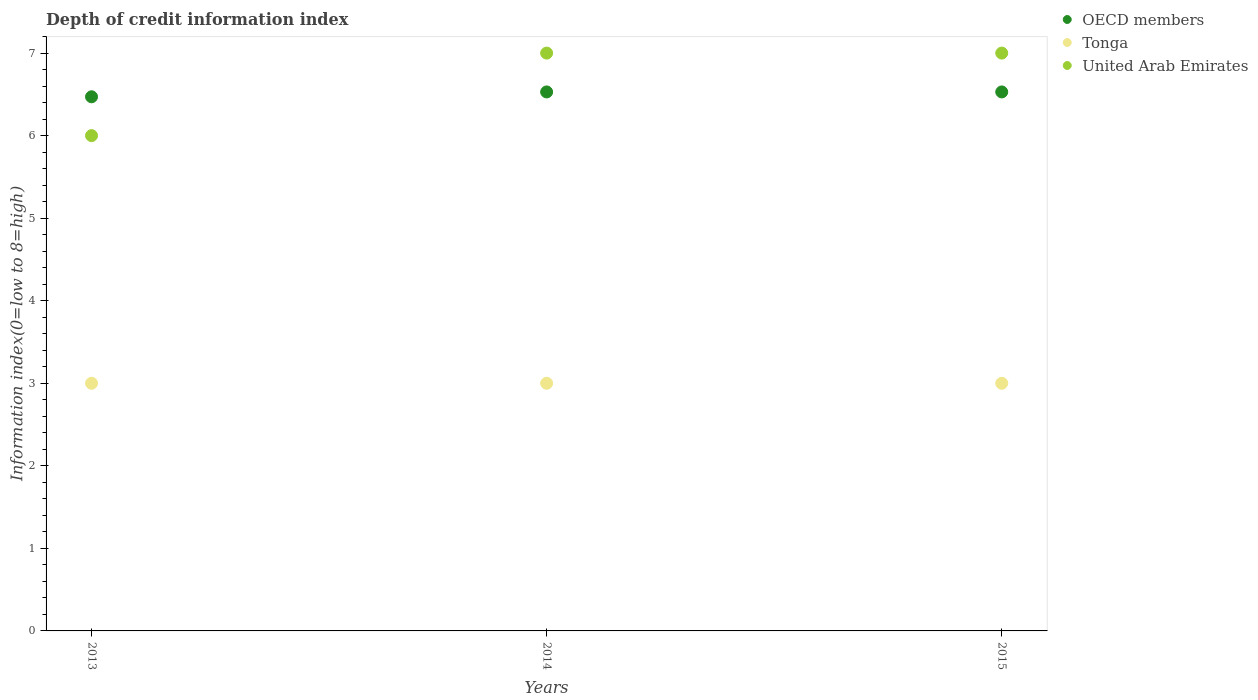How many different coloured dotlines are there?
Ensure brevity in your answer.  3. What is the information index in OECD members in 2014?
Give a very brief answer. 6.53. Across all years, what is the maximum information index in Tonga?
Your answer should be very brief. 3. In which year was the information index in United Arab Emirates maximum?
Keep it short and to the point. 2014. In which year was the information index in Tonga minimum?
Your answer should be compact. 2013. What is the total information index in United Arab Emirates in the graph?
Offer a very short reply. 20. What is the difference between the information index in OECD members in 2013 and that in 2014?
Your answer should be compact. -0.06. What is the difference between the information index in United Arab Emirates in 2015 and the information index in OECD members in 2013?
Keep it short and to the point. 0.53. What is the average information index in OECD members per year?
Give a very brief answer. 6.51. In the year 2014, what is the difference between the information index in OECD members and information index in Tonga?
Provide a short and direct response. 3.53. Is the information index in Tonga in 2013 less than that in 2014?
Provide a short and direct response. No. Is the difference between the information index in OECD members in 2014 and 2015 greater than the difference between the information index in Tonga in 2014 and 2015?
Your answer should be very brief. No. What is the difference between the highest and the second highest information index in Tonga?
Provide a short and direct response. 0. What is the difference between the highest and the lowest information index in United Arab Emirates?
Provide a short and direct response. 1. Is it the case that in every year, the sum of the information index in Tonga and information index in OECD members  is greater than the information index in United Arab Emirates?
Make the answer very short. Yes. Does the information index in OECD members monotonically increase over the years?
Keep it short and to the point. No. Is the information index in OECD members strictly greater than the information index in United Arab Emirates over the years?
Your response must be concise. No. How many dotlines are there?
Provide a succinct answer. 3. How many years are there in the graph?
Keep it short and to the point. 3. What is the difference between two consecutive major ticks on the Y-axis?
Make the answer very short. 1. Are the values on the major ticks of Y-axis written in scientific E-notation?
Offer a very short reply. No. Does the graph contain any zero values?
Provide a short and direct response. No. How many legend labels are there?
Give a very brief answer. 3. What is the title of the graph?
Your response must be concise. Depth of credit information index. What is the label or title of the Y-axis?
Keep it short and to the point. Information index(0=low to 8=high). What is the Information index(0=low to 8=high) of OECD members in 2013?
Ensure brevity in your answer.  6.47. What is the Information index(0=low to 8=high) of United Arab Emirates in 2013?
Offer a terse response. 6. What is the Information index(0=low to 8=high) in OECD members in 2014?
Keep it short and to the point. 6.53. What is the Information index(0=low to 8=high) in OECD members in 2015?
Offer a very short reply. 6.53. What is the Information index(0=low to 8=high) of Tonga in 2015?
Make the answer very short. 3. Across all years, what is the maximum Information index(0=low to 8=high) of OECD members?
Make the answer very short. 6.53. Across all years, what is the maximum Information index(0=low to 8=high) of United Arab Emirates?
Ensure brevity in your answer.  7. Across all years, what is the minimum Information index(0=low to 8=high) of OECD members?
Give a very brief answer. 6.47. What is the total Information index(0=low to 8=high) in OECD members in the graph?
Provide a succinct answer. 19.53. What is the total Information index(0=low to 8=high) of United Arab Emirates in the graph?
Give a very brief answer. 20. What is the difference between the Information index(0=low to 8=high) of OECD members in 2013 and that in 2014?
Make the answer very short. -0.06. What is the difference between the Information index(0=low to 8=high) of Tonga in 2013 and that in 2014?
Give a very brief answer. 0. What is the difference between the Information index(0=low to 8=high) of United Arab Emirates in 2013 and that in 2014?
Provide a succinct answer. -1. What is the difference between the Information index(0=low to 8=high) of OECD members in 2013 and that in 2015?
Ensure brevity in your answer.  -0.06. What is the difference between the Information index(0=low to 8=high) in Tonga in 2013 and that in 2015?
Ensure brevity in your answer.  0. What is the difference between the Information index(0=low to 8=high) of United Arab Emirates in 2013 and that in 2015?
Ensure brevity in your answer.  -1. What is the difference between the Information index(0=low to 8=high) in OECD members in 2014 and that in 2015?
Keep it short and to the point. 0. What is the difference between the Information index(0=low to 8=high) in Tonga in 2014 and that in 2015?
Offer a very short reply. 0. What is the difference between the Information index(0=low to 8=high) of OECD members in 2013 and the Information index(0=low to 8=high) of Tonga in 2014?
Make the answer very short. 3.47. What is the difference between the Information index(0=low to 8=high) of OECD members in 2013 and the Information index(0=low to 8=high) of United Arab Emirates in 2014?
Offer a terse response. -0.53. What is the difference between the Information index(0=low to 8=high) of OECD members in 2013 and the Information index(0=low to 8=high) of Tonga in 2015?
Give a very brief answer. 3.47. What is the difference between the Information index(0=low to 8=high) of OECD members in 2013 and the Information index(0=low to 8=high) of United Arab Emirates in 2015?
Keep it short and to the point. -0.53. What is the difference between the Information index(0=low to 8=high) of OECD members in 2014 and the Information index(0=low to 8=high) of Tonga in 2015?
Give a very brief answer. 3.53. What is the difference between the Information index(0=low to 8=high) in OECD members in 2014 and the Information index(0=low to 8=high) in United Arab Emirates in 2015?
Provide a succinct answer. -0.47. What is the average Information index(0=low to 8=high) of OECD members per year?
Make the answer very short. 6.51. What is the average Information index(0=low to 8=high) of Tonga per year?
Offer a very short reply. 3. What is the average Information index(0=low to 8=high) in United Arab Emirates per year?
Offer a terse response. 6.67. In the year 2013, what is the difference between the Information index(0=low to 8=high) of OECD members and Information index(0=low to 8=high) of Tonga?
Offer a terse response. 3.47. In the year 2013, what is the difference between the Information index(0=low to 8=high) in OECD members and Information index(0=low to 8=high) in United Arab Emirates?
Provide a short and direct response. 0.47. In the year 2013, what is the difference between the Information index(0=low to 8=high) in Tonga and Information index(0=low to 8=high) in United Arab Emirates?
Your answer should be compact. -3. In the year 2014, what is the difference between the Information index(0=low to 8=high) of OECD members and Information index(0=low to 8=high) of Tonga?
Make the answer very short. 3.53. In the year 2014, what is the difference between the Information index(0=low to 8=high) in OECD members and Information index(0=low to 8=high) in United Arab Emirates?
Keep it short and to the point. -0.47. In the year 2014, what is the difference between the Information index(0=low to 8=high) of Tonga and Information index(0=low to 8=high) of United Arab Emirates?
Ensure brevity in your answer.  -4. In the year 2015, what is the difference between the Information index(0=low to 8=high) of OECD members and Information index(0=low to 8=high) of Tonga?
Your response must be concise. 3.53. In the year 2015, what is the difference between the Information index(0=low to 8=high) in OECD members and Information index(0=low to 8=high) in United Arab Emirates?
Keep it short and to the point. -0.47. What is the ratio of the Information index(0=low to 8=high) in United Arab Emirates in 2013 to that in 2014?
Provide a succinct answer. 0.86. What is the ratio of the Information index(0=low to 8=high) in Tonga in 2013 to that in 2015?
Give a very brief answer. 1. What is the ratio of the Information index(0=low to 8=high) of United Arab Emirates in 2013 to that in 2015?
Ensure brevity in your answer.  0.86. What is the ratio of the Information index(0=low to 8=high) in OECD members in 2014 to that in 2015?
Give a very brief answer. 1. What is the ratio of the Information index(0=low to 8=high) of Tonga in 2014 to that in 2015?
Keep it short and to the point. 1. What is the difference between the highest and the second highest Information index(0=low to 8=high) in Tonga?
Provide a succinct answer. 0. What is the difference between the highest and the second highest Information index(0=low to 8=high) of United Arab Emirates?
Give a very brief answer. 0. What is the difference between the highest and the lowest Information index(0=low to 8=high) in OECD members?
Give a very brief answer. 0.06. What is the difference between the highest and the lowest Information index(0=low to 8=high) in United Arab Emirates?
Provide a succinct answer. 1. 